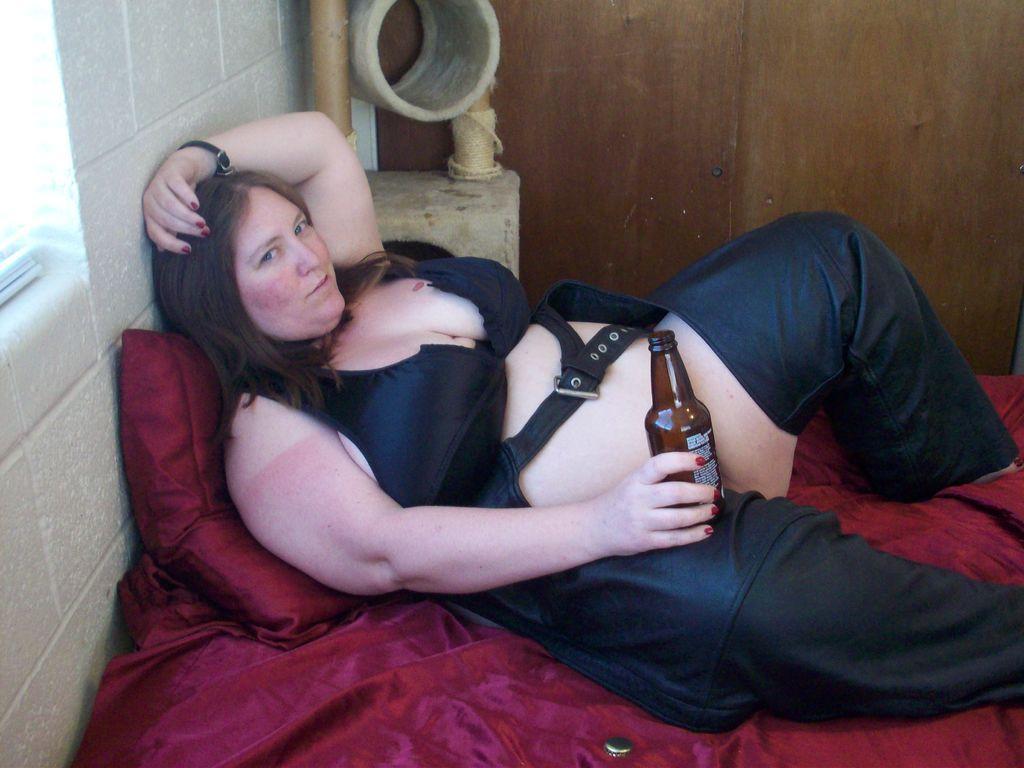Could you give a brief overview of what you see in this image? This woman is laying on this bed with pillow, wore black dress and holding bottle. 